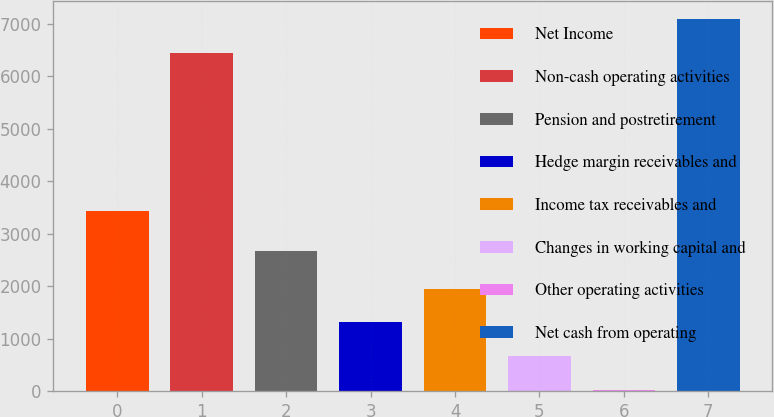Convert chart to OTSL. <chart><loc_0><loc_0><loc_500><loc_500><bar_chart><fcel>Net Income<fcel>Non-cash operating activities<fcel>Pension and postretirement<fcel>Hedge margin receivables and<fcel>Income tax receivables and<fcel>Changes in working capital and<fcel>Other operating activities<fcel>Net cash from operating<nl><fcel>3431<fcel>6444<fcel>2668<fcel>1314.6<fcel>1959.4<fcel>669.8<fcel>25<fcel>7088.8<nl></chart> 